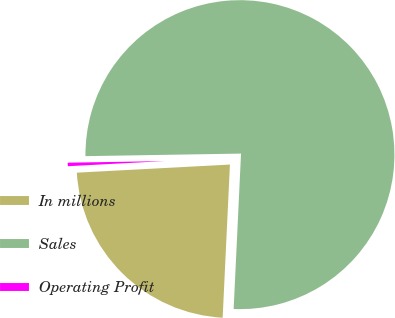<chart> <loc_0><loc_0><loc_500><loc_500><pie_chart><fcel>In millions<fcel>Sales<fcel>Operating Profit<nl><fcel>23.4%<fcel>76.01%<fcel>0.58%<nl></chart> 